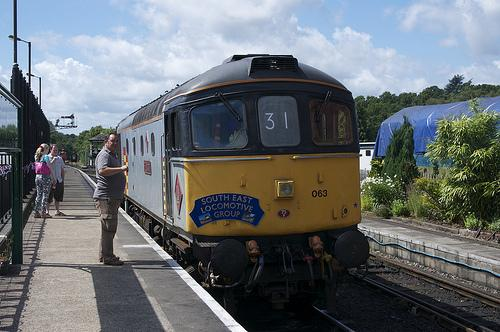Mention the two main colors of the sky in the image and specify any visible natural element. The sky is blue and has white clouds. What does the sign on the train say, and what is its color? The sign on the train is blue and says "south east locomotive group." What are the people on the sidewalk doing? People are standing on the sidewalk and talking to each other, waiting for the train. Mention any unique feature about the train's windows. The number 31 is visible on the front train window. What type of plants can be seen near the platform? There are green plants, trees, and shrubberies near the platform. Describe the relationship between the man and the woman on the platform. The man and woman on the platform seem to be having a conversation, perhaps acquaintances or friends. Describe the appearance of the man standing beside the train and his attire. The man is an adult white man wearing a grey shirt, tan cargo pants, and brown shoes. Point out any interesting aspect about the train's front bumper. The front bumper of the train is yellow and has the number 63. List down three objects that can be found on the train platform. People, train tracks, and street lights can be found on the train platform. Identify the color and number displayed on the train. The train is yellow and has the number 31 on it. What are your thoughts on the large graffiti mural on the side of the train? It has a very unique design! No, it's not mentioned in the image. 